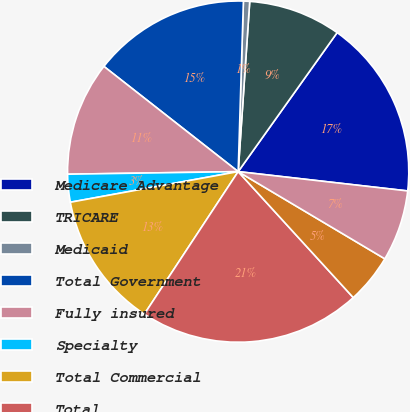Convert chart. <chart><loc_0><loc_0><loc_500><loc_500><pie_chart><fcel>Medicare Advantage<fcel>TRICARE<fcel>Medicaid<fcel>Total Government<fcel>Fully insured<fcel>Specialty<fcel>Total Commercial<fcel>Total<fcel>Government<fcel>Commercial<nl><fcel>16.96%<fcel>8.77%<fcel>0.59%<fcel>14.91%<fcel>10.82%<fcel>2.63%<fcel>12.86%<fcel>21.05%<fcel>4.68%<fcel>6.73%<nl></chart> 